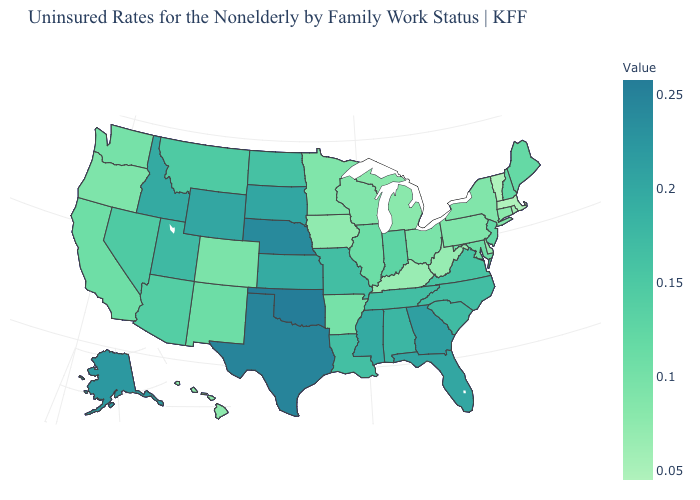Is the legend a continuous bar?
Be succinct. Yes. Does Nebraska have the highest value in the MidWest?
Answer briefly. Yes. Does New Hampshire have a higher value than Connecticut?
Concise answer only. Yes. Does Louisiana have the lowest value in the USA?
Quick response, please. No. Does Iowa have the lowest value in the MidWest?
Write a very short answer. Yes. 